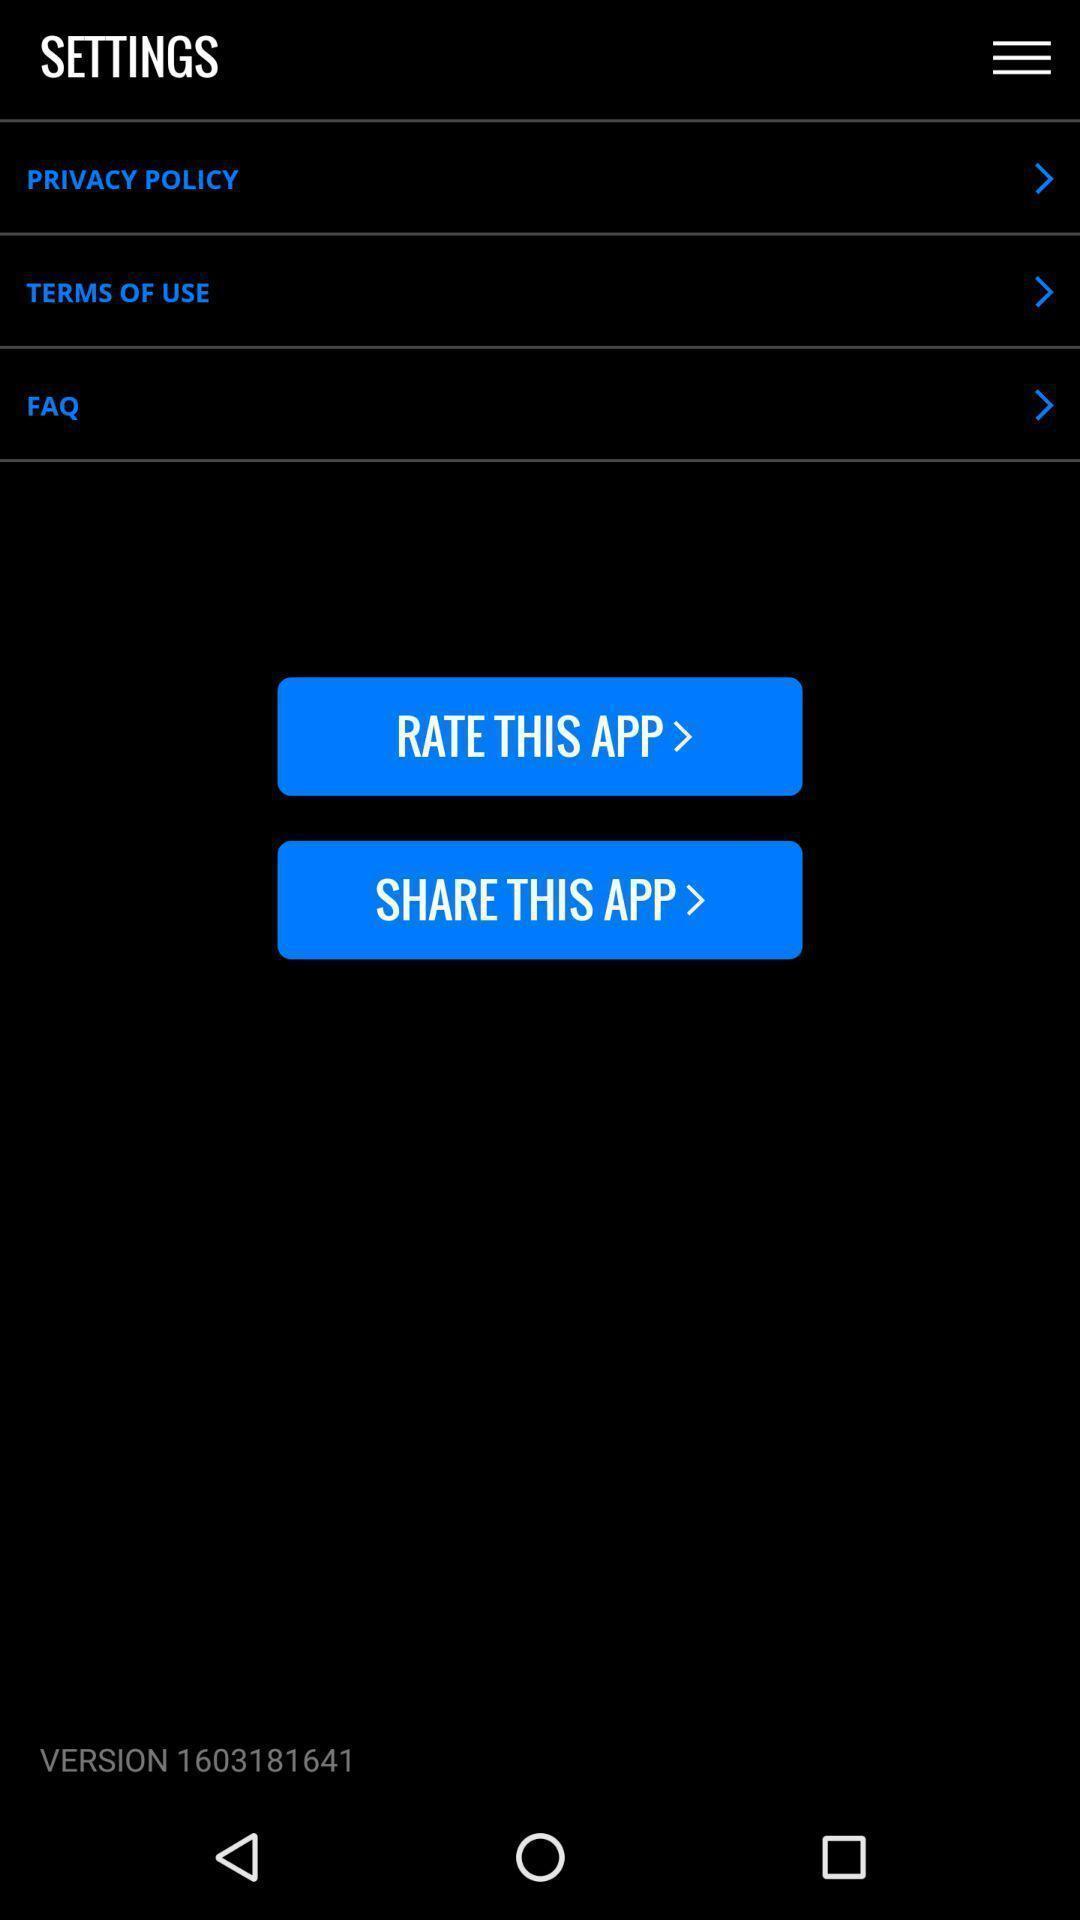Give me a narrative description of this picture. Screen showing settings page with options. 